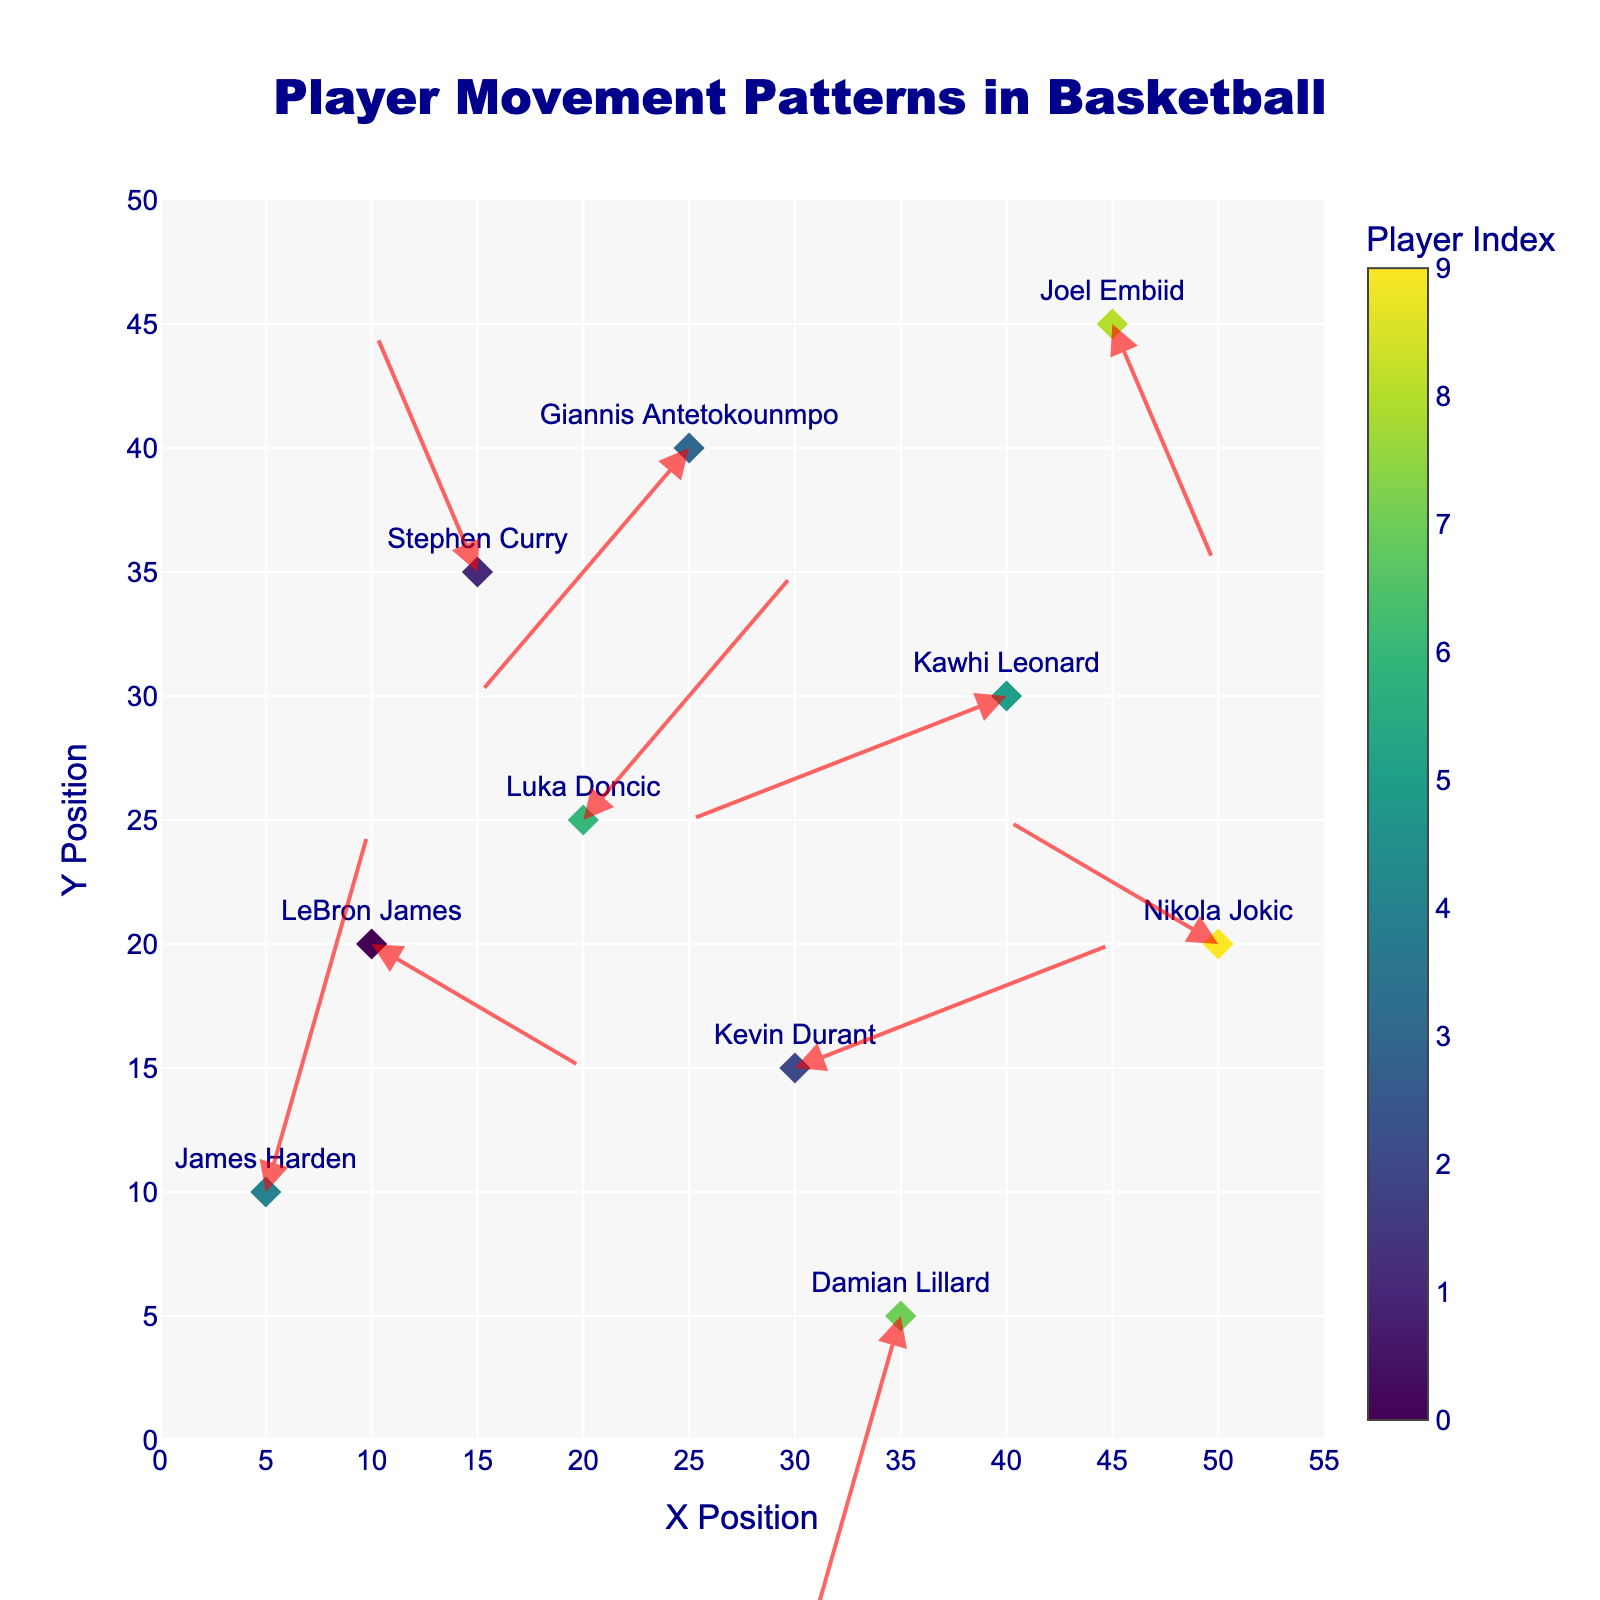What is the title of the figure? The title is displayed at the top center of the figure and reads "Player Movement Patterns in Basketball".
Answer: Player Movement Patterns in Basketball How many players' movements are represented in the figure? The figure shows markers and annotations for each player. Counting them gives a total of 10 players.
Answer: 10 Which player has the longest movement vector in the plot? By visually estimating, Kevin Durant has the longest arrow, represented by a noticeable diagonal rightward and upward movement.
Answer: Kevin Durant Which player’s movement ends closest to (0, 0)? James Harden moves from (5, 10) with a vector (1, 3), placing his end position at (6, 13), which is closest to (0, 0) compared to others.
Answer: James Harden Which two players have movements that are in nearly opposite directions? Giannis Antetokounmpo (vector (-2, -2)) and Luka Doncic (vector (2, 2)) have approximately opposite vectors.
Answer: Giannis Antetokounmpo and Luka Doncic What quadrant does Stephen Curry's movement end up in? Starting at (15, 35) with a vector of (-1, 2), Stephen Curry's movement ends in the second quadrant.
Answer: Second quadrant Which player moves horizontally to the left and vertically downwards? Kawhi Leonard moves from (40, 30) with a vector of (-3, -1), indicating leftward and downward movement.
Answer: Kawhi Leonard What player movement vectors are equal or nearly equal in length? By comparing the lengths, LeBron James (2, -1), Luka Doncic (2, 2), Kevin Durant (3, 1), and Nikola Jokic (-2, 1) movements are similar in length when calculated (all approximately √5).
Answer: LeBron James, Luka Doncic, Kevin Durant, Nikola Jokic Which player has the most vertical upward movement? James Harden moves from (5, 10) with a vector of (1, 3), indicating the largest positive vertical movement.
Answer: James Harden What is the average x-coordinate of the player starting positions? The starting x-coordinates are 10, 15, 30, 25, 5, 40, 20, 35, 45, and 50. Summing them (10+15+30+25+5+40+20+35+45+50) equals 275, and the average is 275/10.
Answer: 27.5 